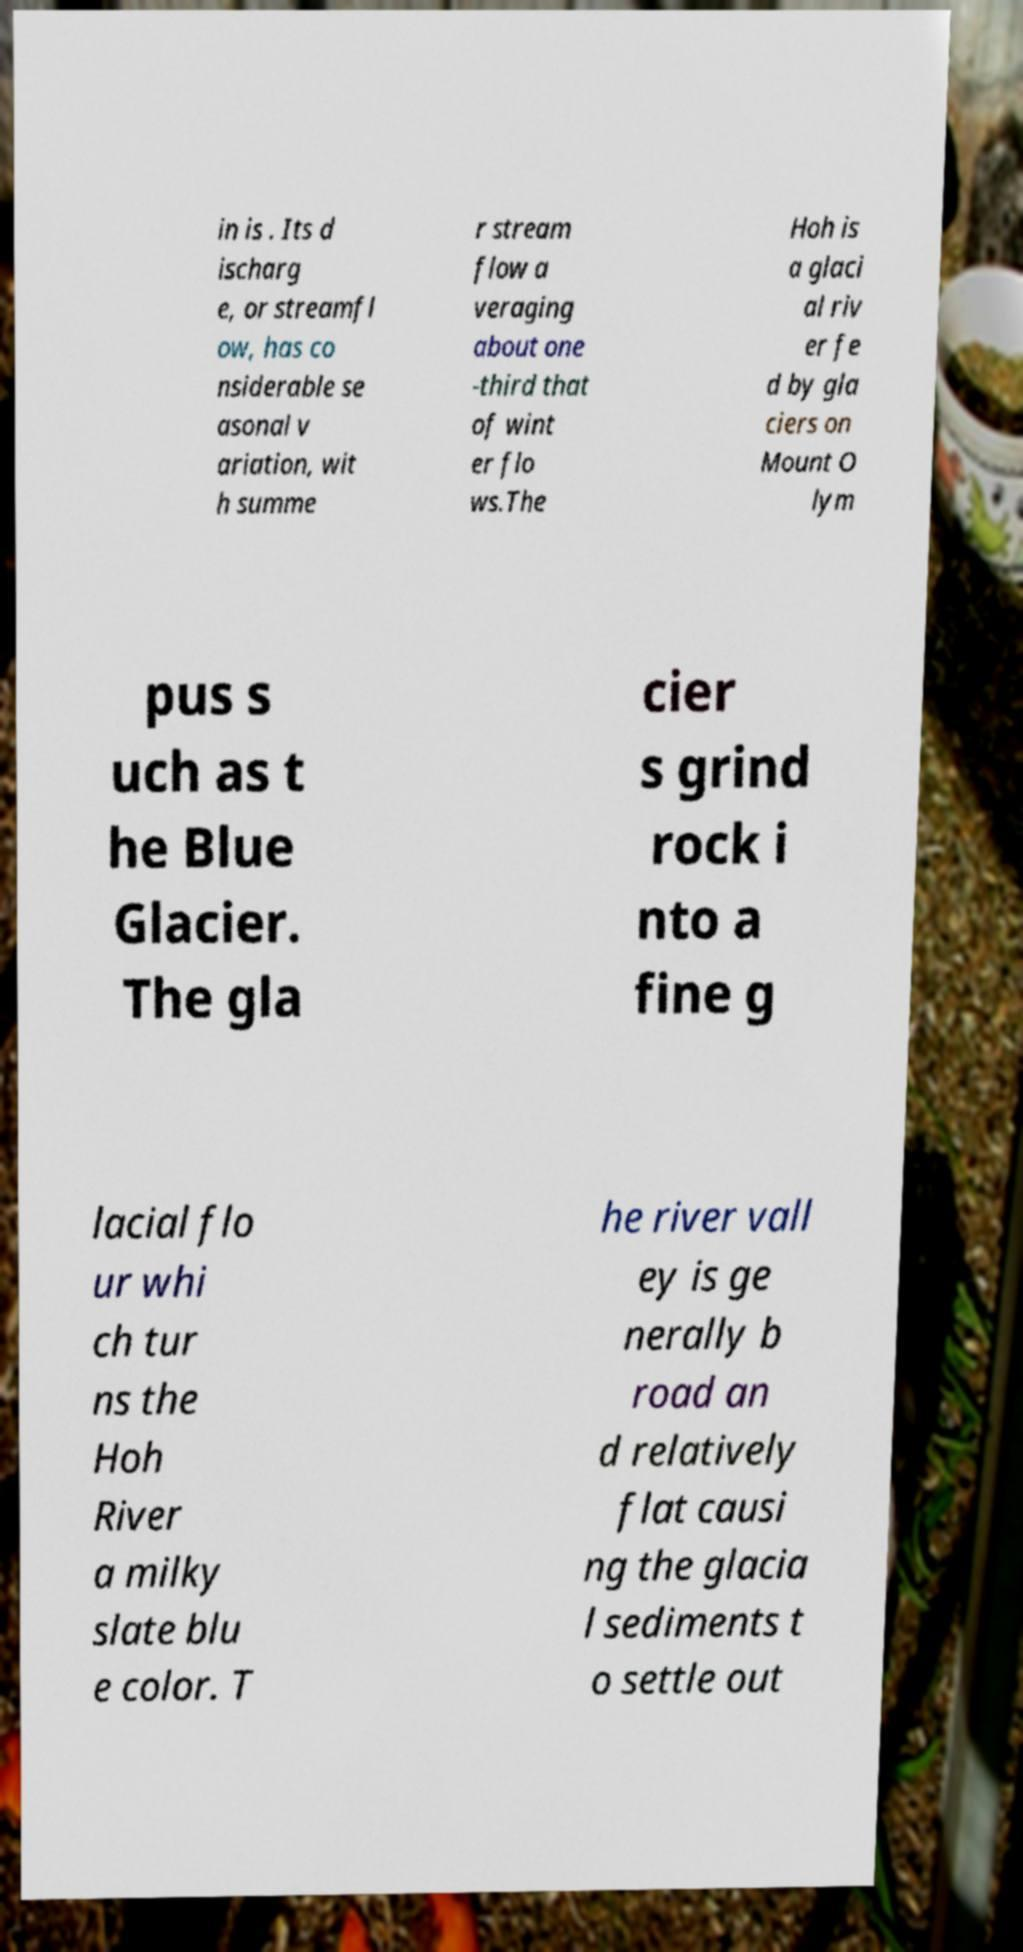Please read and relay the text visible in this image. What does it say? in is . Its d ischarg e, or streamfl ow, has co nsiderable se asonal v ariation, wit h summe r stream flow a veraging about one -third that of wint er flo ws.The Hoh is a glaci al riv er fe d by gla ciers on Mount O lym pus s uch as t he Blue Glacier. The gla cier s grind rock i nto a fine g lacial flo ur whi ch tur ns the Hoh River a milky slate blu e color. T he river vall ey is ge nerally b road an d relatively flat causi ng the glacia l sediments t o settle out 